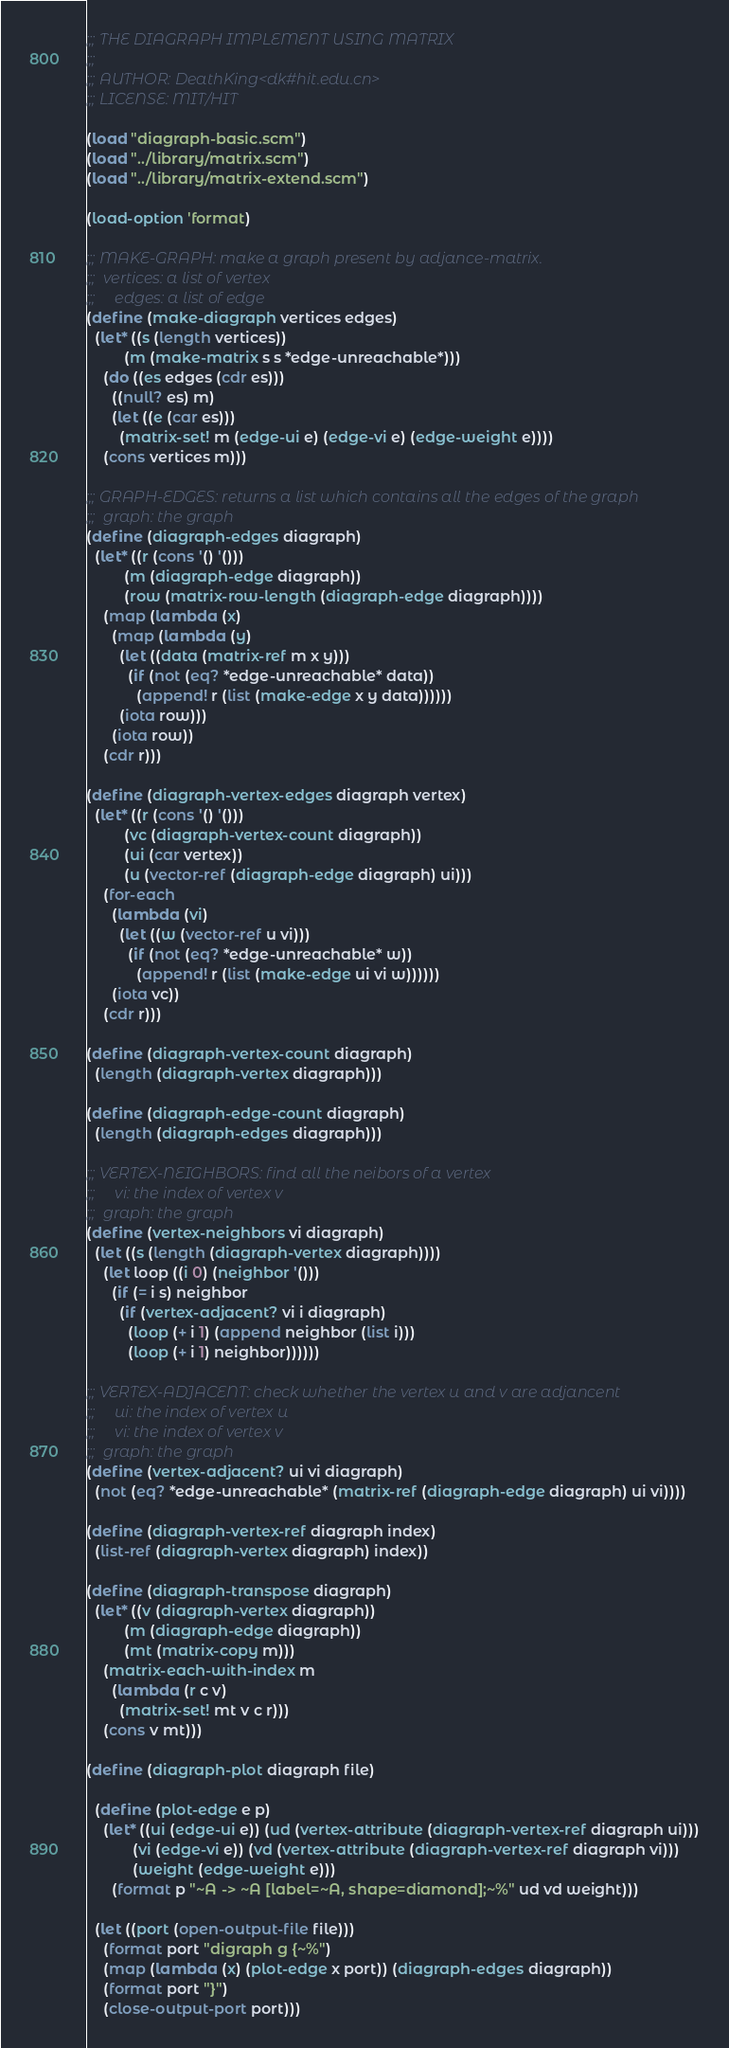Convert code to text. <code><loc_0><loc_0><loc_500><loc_500><_Scheme_>;;; THE DIAGRAPH IMPLEMENT USING MATRIX
;;; 
;;; AUTHOR: DeathKing<dk#hit.edu.cn>
;;; LICENSE: MIT/HIT

(load "diagraph-basic.scm")
(load "../library/matrix.scm")
(load "../library/matrix-extend.scm")

(load-option 'format)

;;; MAKE-GRAPH: make a graph present by adjance-matrix.
;;;  vertices: a list of vertex
;;;     edges: a list of edge
(define (make-diagraph vertices edges)
  (let* ((s (length vertices))
         (m (make-matrix s s *edge-unreachable*)))
    (do ((es edges (cdr es)))
      ((null? es) m)
      (let ((e (car es)))
        (matrix-set! m (edge-ui e) (edge-vi e) (edge-weight e))))
    (cons vertices m)))

;;; GRAPH-EDGES: returns a list which contains all the edges of the graph
;;;  graph: the graph
(define (diagraph-edges diagraph)
  (let* ((r (cons '() '()))
         (m (diagraph-edge diagraph))
         (row (matrix-row-length (diagraph-edge diagraph))))
    (map (lambda (x)
      (map (lambda (y)
        (let ((data (matrix-ref m x y)))
          (if (not (eq? *edge-unreachable* data))
            (append! r (list (make-edge x y data))))))
        (iota row)))
      (iota row))
    (cdr r)))

(define (diagraph-vertex-edges diagraph vertex)
  (let* ((r (cons '() '()))
         (vc (diagraph-vertex-count diagraph))
         (ui (car vertex))
         (u (vector-ref (diagraph-edge diagraph) ui)))
    (for-each
      (lambda (vi)
        (let ((w (vector-ref u vi)))
          (if (not (eq? *edge-unreachable* w))
            (append! r (list (make-edge ui vi w))))))
      (iota vc))
    (cdr r)))

(define (diagraph-vertex-count diagraph)
  (length (diagraph-vertex diagraph)))

(define (diagraph-edge-count diagraph)
  (length (diagraph-edges diagraph)))

;;; VERTEX-NEIGHBORS: find all the neibors of a vertex
;;;     vi: the index of vertex v
;;;  graph: the graph
(define (vertex-neighbors vi diagraph)
  (let ((s (length (diagraph-vertex diagraph))))
    (let loop ((i 0) (neighbor '()))
      (if (= i s) neighbor
        (if (vertex-adjacent? vi i diagraph)
          (loop (+ i 1) (append neighbor (list i)))
          (loop (+ i 1) neighbor))))))

;;; VERTEX-ADJACENT: check whether the vertex u and v are adjancent
;;;     ui: the index of vertex u
;;;     vi: the index of vertex v
;;;  graph: the graph
(define (vertex-adjacent? ui vi diagraph)
  (not (eq? *edge-unreachable* (matrix-ref (diagraph-edge diagraph) ui vi))))

(define (diagraph-vertex-ref diagraph index)
  (list-ref (diagraph-vertex diagraph) index))

(define (diagraph-transpose diagraph)
  (let* ((v (diagraph-vertex diagraph))
         (m (diagraph-edge diagraph))
         (mt (matrix-copy m)))
    (matrix-each-with-index m
      (lambda (r c v)
        (matrix-set! mt v c r)))
    (cons v mt)))

(define (diagraph-plot diagraph file)
  
  (define (plot-edge e p)
    (let* ((ui (edge-ui e)) (ud (vertex-attribute (diagraph-vertex-ref diagraph ui)))
           (vi (edge-vi e)) (vd (vertex-attribute (diagraph-vertex-ref diagraph vi)))
           (weight (edge-weight e)))
      (format p "~A -> ~A [label=~A, shape=diamond];~%" ud vd weight)))

  (let ((port (open-output-file file)))
    (format port "digraph g {~%")
    (map (lambda (x) (plot-edge x port)) (diagraph-edges diagraph))
    (format port "}")
    (close-output-port port)))</code> 